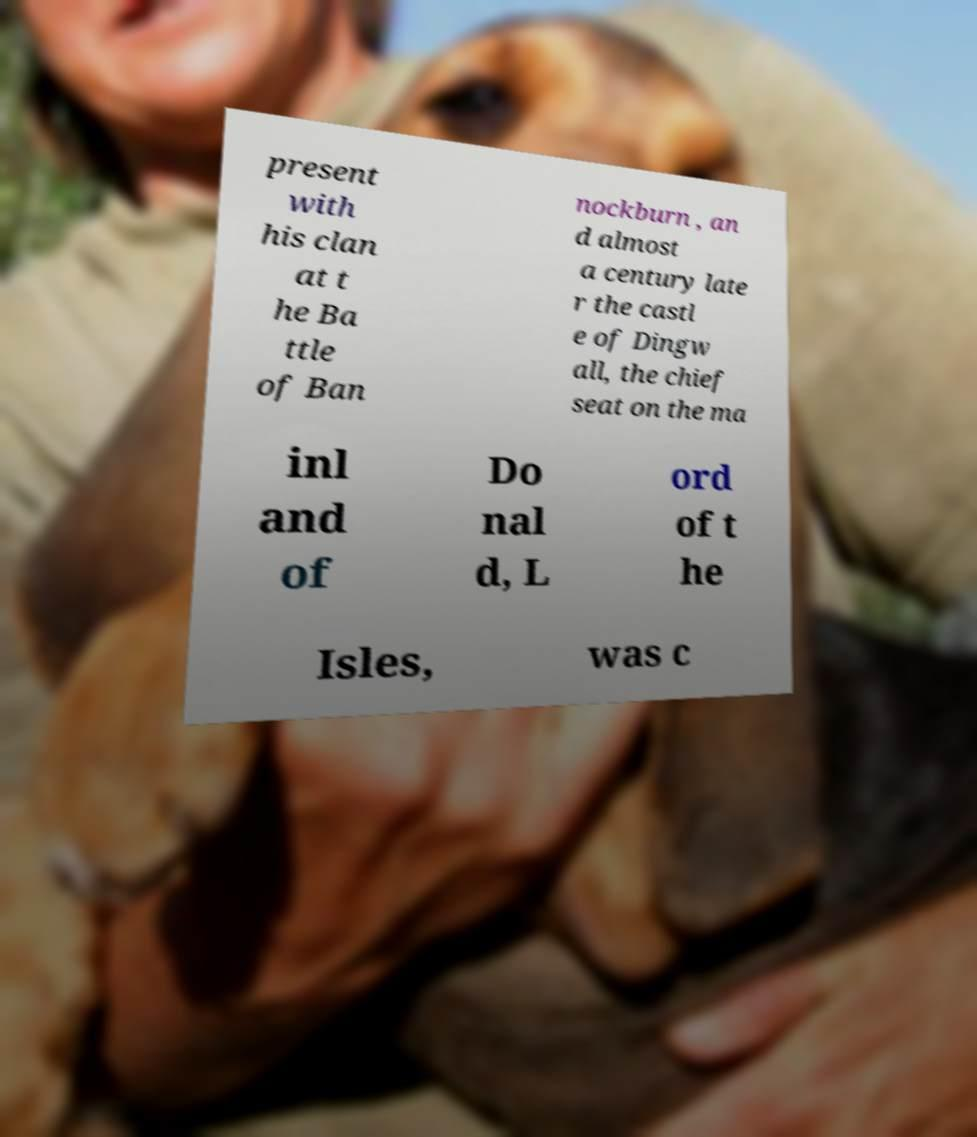Could you extract and type out the text from this image? present with his clan at t he Ba ttle of Ban nockburn , an d almost a century late r the castl e of Dingw all, the chief seat on the ma inl and of Do nal d, L ord of t he Isles, was c 